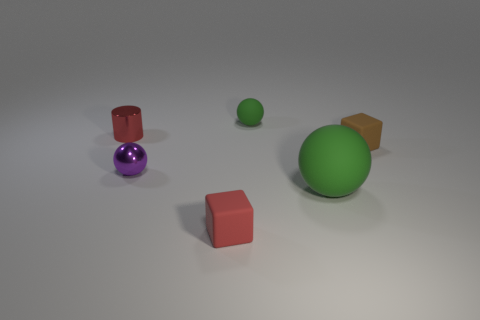There is a ball that is right of the red rubber cube and behind the large ball; what is its size? The ball to the right of the red cube and behind the large green ball appears to be small in size, similar to the purple ball in the foreground. 